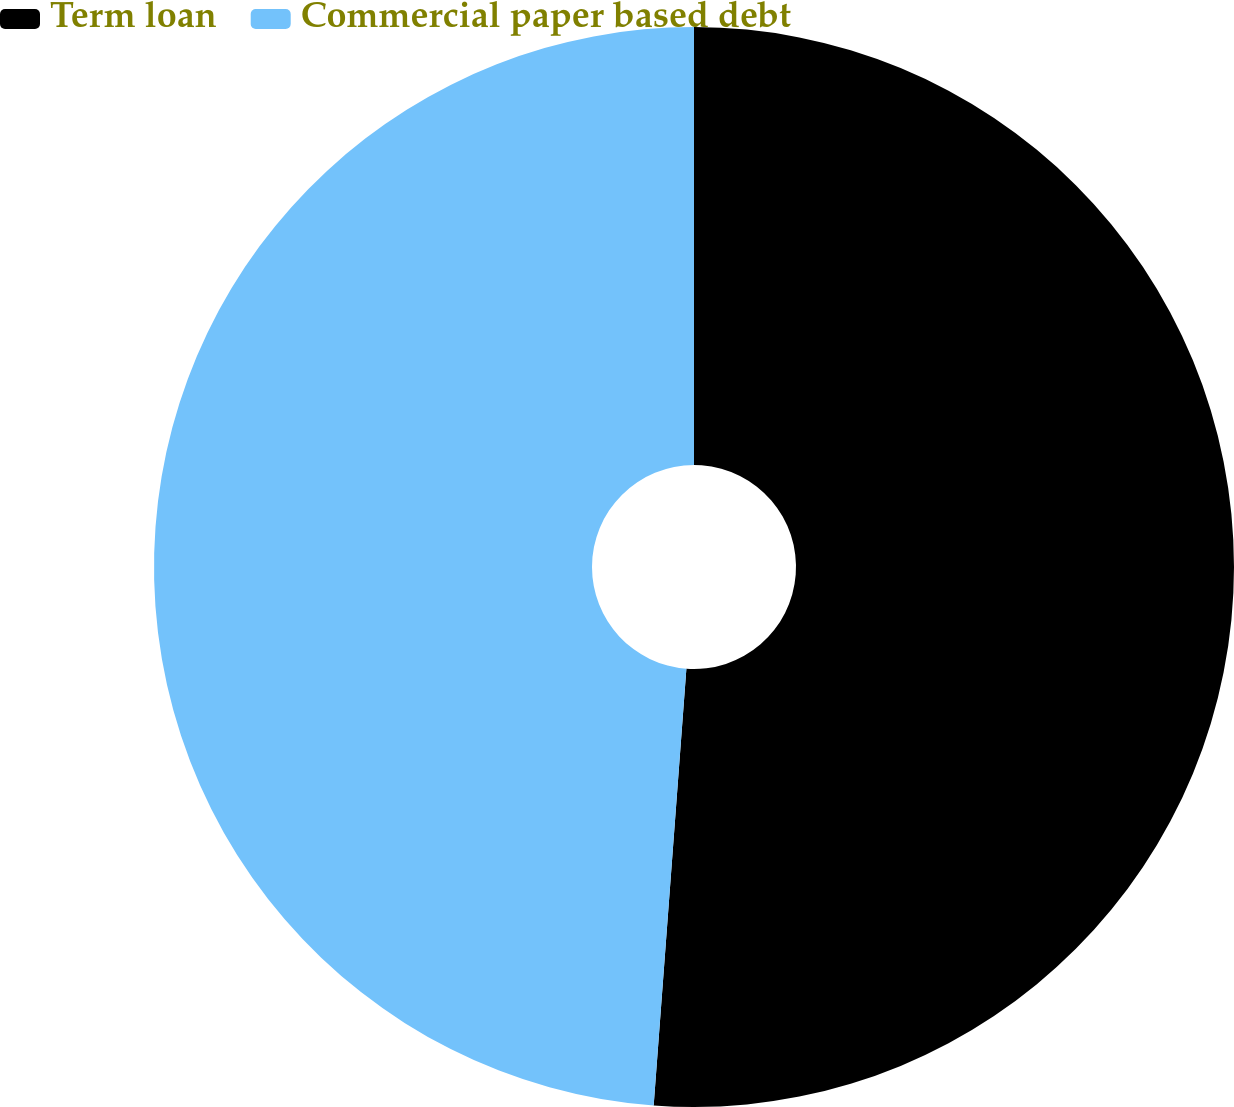Convert chart to OTSL. <chart><loc_0><loc_0><loc_500><loc_500><pie_chart><fcel>Term loan<fcel>Commercial paper based debt<nl><fcel>51.19%<fcel>48.81%<nl></chart> 